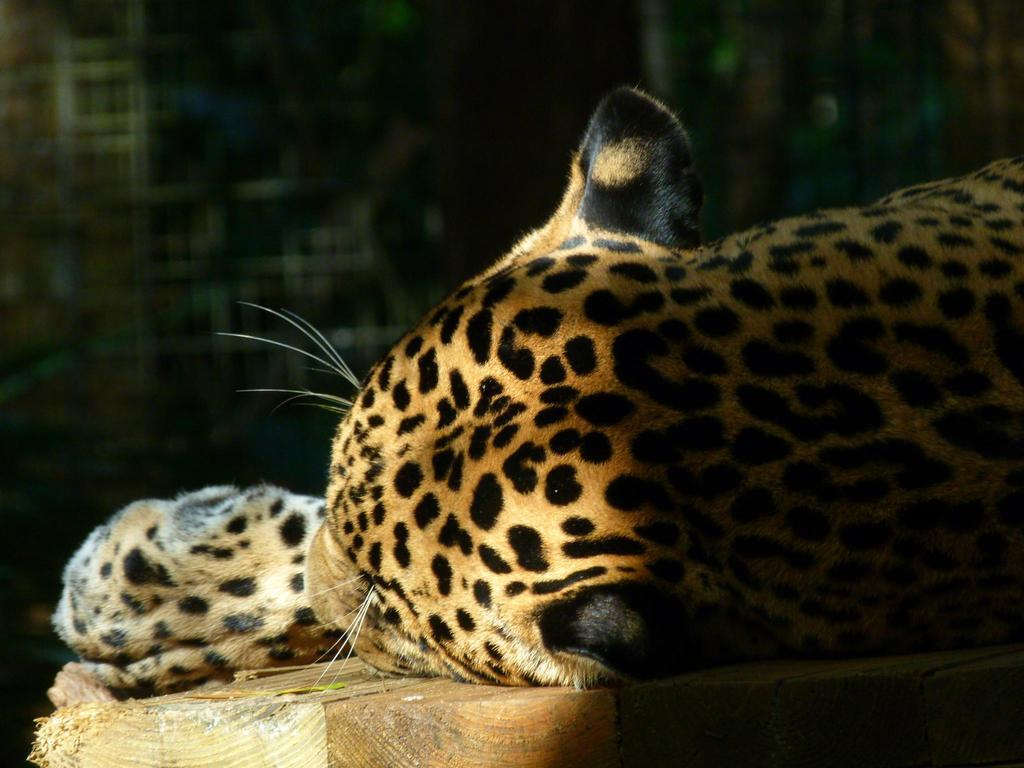What animal is the main subject of the image? There is a cheetah in the image. Can you describe the coloring of the cheetah? The cheetah has orange, black, and white coloring. What is the cheetah laying on in the image? The cheetah is laying on a wooden surface. What color is the wooden surface? The wooden surface is brown in color. What can be observed about the background of the image? The background of the image is dark. What type of chair is the governor sitting on in the image? There is no governor or chair present in the image; it features a cheetah laying on a wooden surface. Can you tell me how many kitties are playing with the cheetah in the image? There are no kitties present in the image; it features a cheetah laying on a wooden surface. 